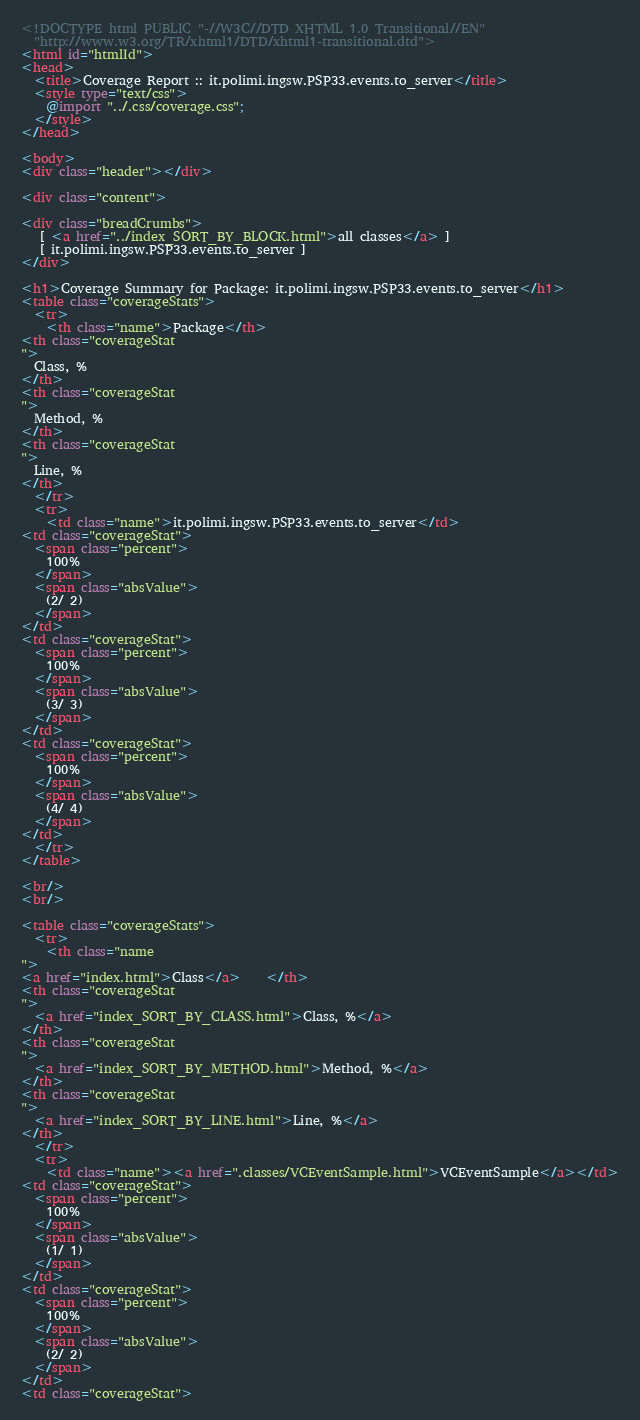<code> <loc_0><loc_0><loc_500><loc_500><_HTML_>
<!DOCTYPE html PUBLIC "-//W3C//DTD XHTML 1.0 Transitional//EN"
  "http://www.w3.org/TR/xhtml1/DTD/xhtml1-transitional.dtd">
<html id="htmlId">
<head>
  <title>Coverage Report :: it.polimi.ingsw.PSP33.events.to_server</title>
  <style type="text/css">
    @import "../.css/coverage.css";
  </style>
</head>

<body>
<div class="header"></div>

<div class="content">

<div class="breadCrumbs">
   [ <a href="../index_SORT_BY_BLOCK.html">all classes</a> ]
   [ it.polimi.ingsw.PSP33.events.to_server ]
</div>

<h1>Coverage Summary for Package: it.polimi.ingsw.PSP33.events.to_server</h1>
<table class="coverageStats">
  <tr>
    <th class="name">Package</th>
<th class="coverageStat 
">
  Class, %
</th>
<th class="coverageStat 
">
  Method, %
</th>
<th class="coverageStat 
">
  Line, %
</th>
  </tr>
  <tr>
    <td class="name">it.polimi.ingsw.PSP33.events.to_server</td>
<td class="coverageStat">
  <span class="percent">
    100%
  </span>
  <span class="absValue">
    (2/ 2)
  </span>
</td>
<td class="coverageStat">
  <span class="percent">
    100%
  </span>
  <span class="absValue">
    (3/ 3)
  </span>
</td>
<td class="coverageStat">
  <span class="percent">
    100%
  </span>
  <span class="absValue">
    (4/ 4)
  </span>
</td>
  </tr>
</table>

<br/>
<br/>

<table class="coverageStats">
  <tr>
    <th class="name  
">
<a href="index.html">Class</a>    </th>
<th class="coverageStat 
">
  <a href="index_SORT_BY_CLASS.html">Class, %</a>
</th>
<th class="coverageStat 
">
  <a href="index_SORT_BY_METHOD.html">Method, %</a>
</th>
<th class="coverageStat 
">
  <a href="index_SORT_BY_LINE.html">Line, %</a>
</th>
  </tr>
  <tr>
    <td class="name"><a href=".classes/VCEventSample.html">VCEventSample</a></td>
<td class="coverageStat">
  <span class="percent">
    100%
  </span>
  <span class="absValue">
    (1/ 1)
  </span>
</td>
<td class="coverageStat">
  <span class="percent">
    100%
  </span>
  <span class="absValue">
    (2/ 2)
  </span>
</td>
<td class="coverageStat"></code> 